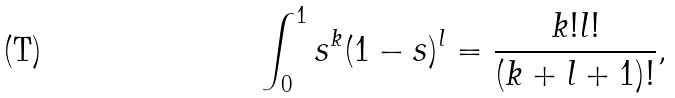<formula> <loc_0><loc_0><loc_500><loc_500>\int _ { 0 } ^ { 1 } s ^ { k } ( 1 - s ) ^ { l } = \frac { k ! l ! } { ( k + l + 1 ) ! } ,</formula> 